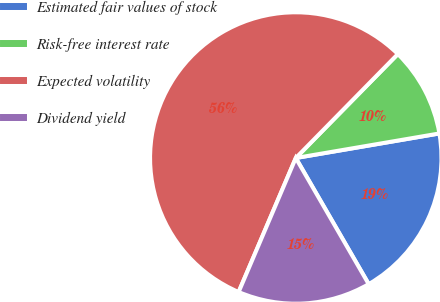<chart> <loc_0><loc_0><loc_500><loc_500><pie_chart><fcel>Estimated fair values of stock<fcel>Risk-free interest rate<fcel>Expected volatility<fcel>Dividend yield<nl><fcel>19.35%<fcel>9.95%<fcel>55.94%<fcel>14.76%<nl></chart> 